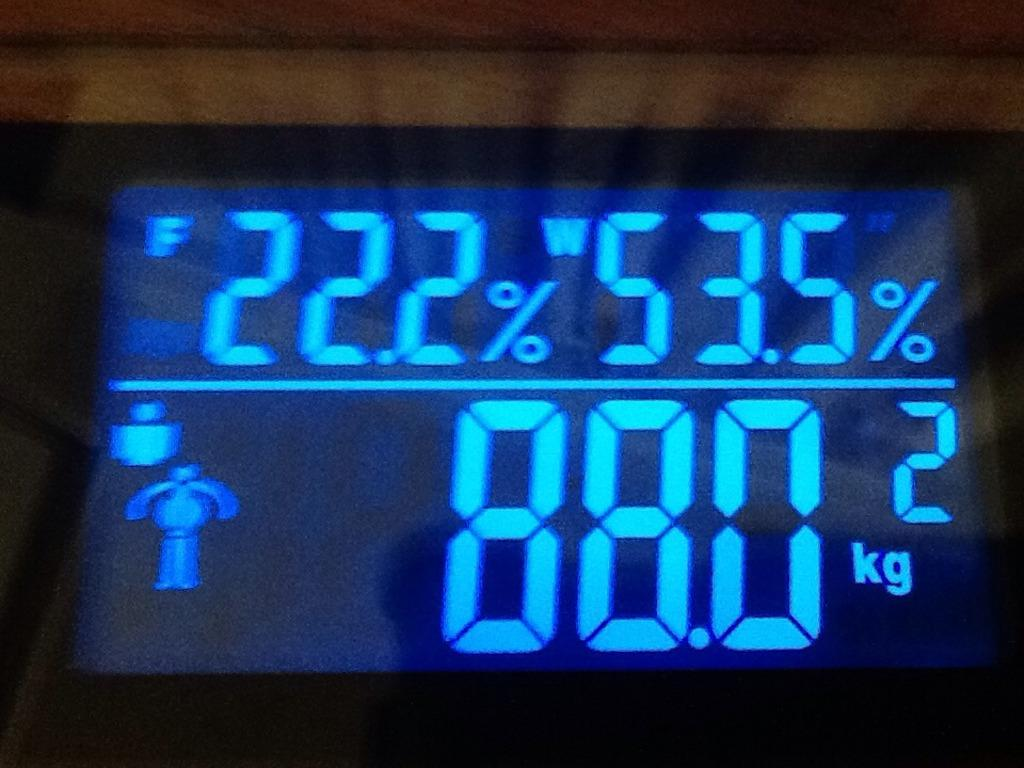<image>
Write a terse but informative summary of the picture. The display of a scale indicates that something weights 88 kilograms. 